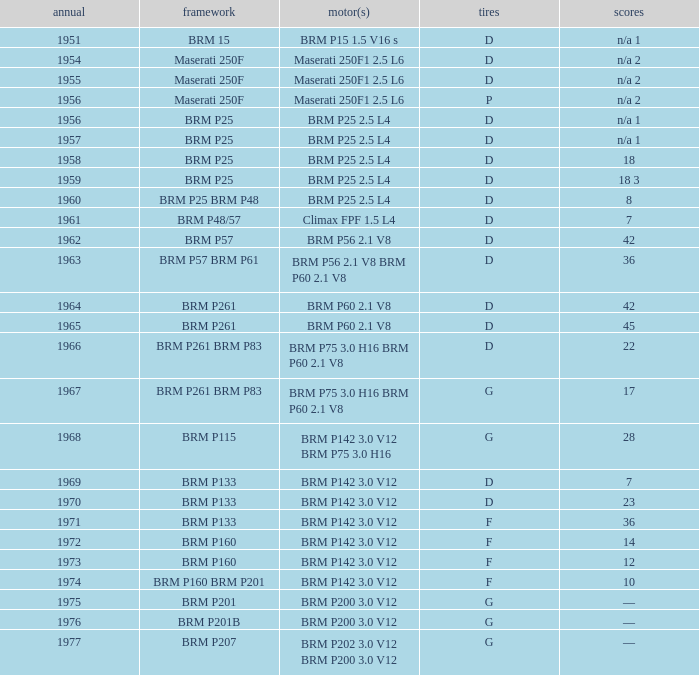Name the chassis for 1970 and tyres of d BRM P133. 